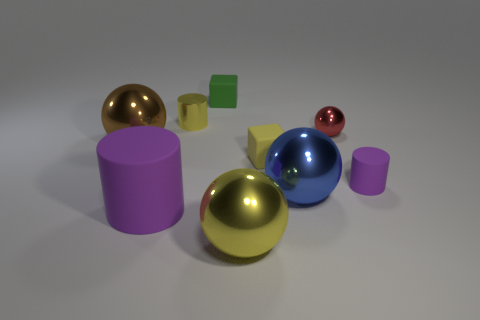What size is the thing that is the same color as the big cylinder?
Give a very brief answer. Small. How many metallic objects are cyan balls or blue things?
Keep it short and to the point. 1. Is there a big blue metal sphere that is behind the large metallic object that is in front of the large rubber object in front of the small red sphere?
Provide a succinct answer. Yes. How many red shiny things are to the left of the big blue metal thing?
Make the answer very short. 0. What material is the cube that is the same color as the metallic cylinder?
Your answer should be compact. Rubber. How many large objects are purple cylinders or purple metal spheres?
Provide a succinct answer. 1. What shape is the small metallic thing on the left side of the small green matte thing?
Provide a succinct answer. Cylinder. Are there any balls that have the same color as the tiny metal cylinder?
Your response must be concise. Yes. There is a sphere that is to the right of the big blue sphere; is it the same size as the yellow shiny thing in front of the brown sphere?
Offer a terse response. No. Is the number of yellow metallic things in front of the large cylinder greater than the number of red balls left of the large brown shiny thing?
Make the answer very short. Yes. 